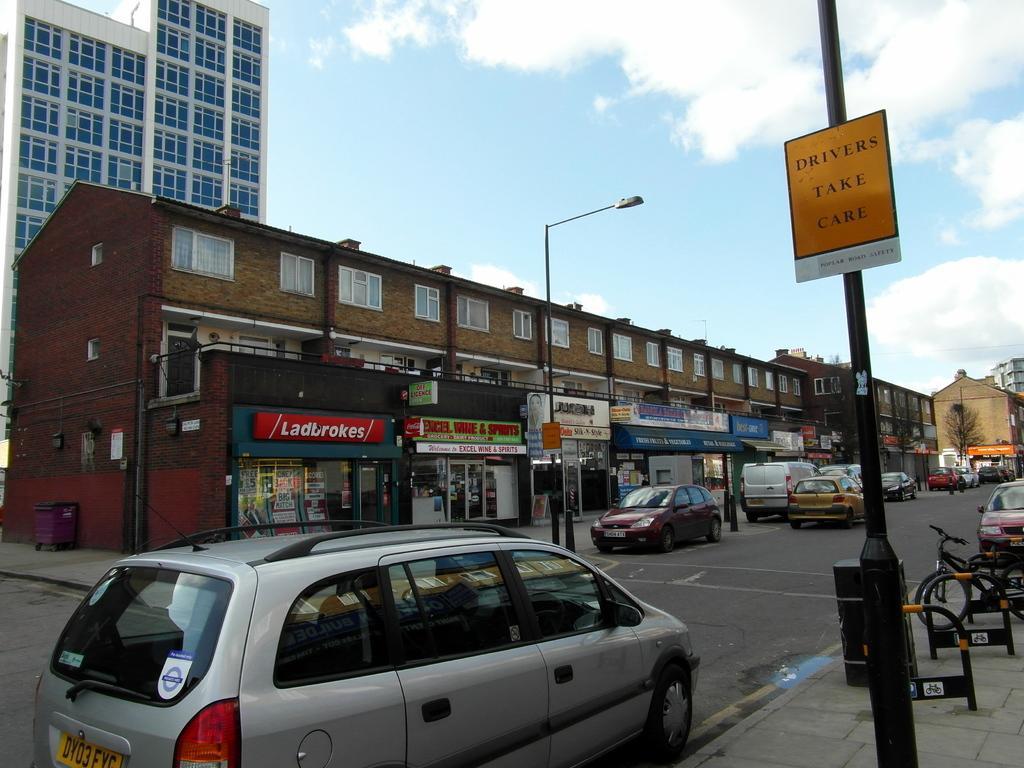Describe this image in one or two sentences. In this image we can see buildings, stores. There are cars on the road. There are light poles. There is a pole with a board with some text on it. At the top of the image there is sky and clouds. 